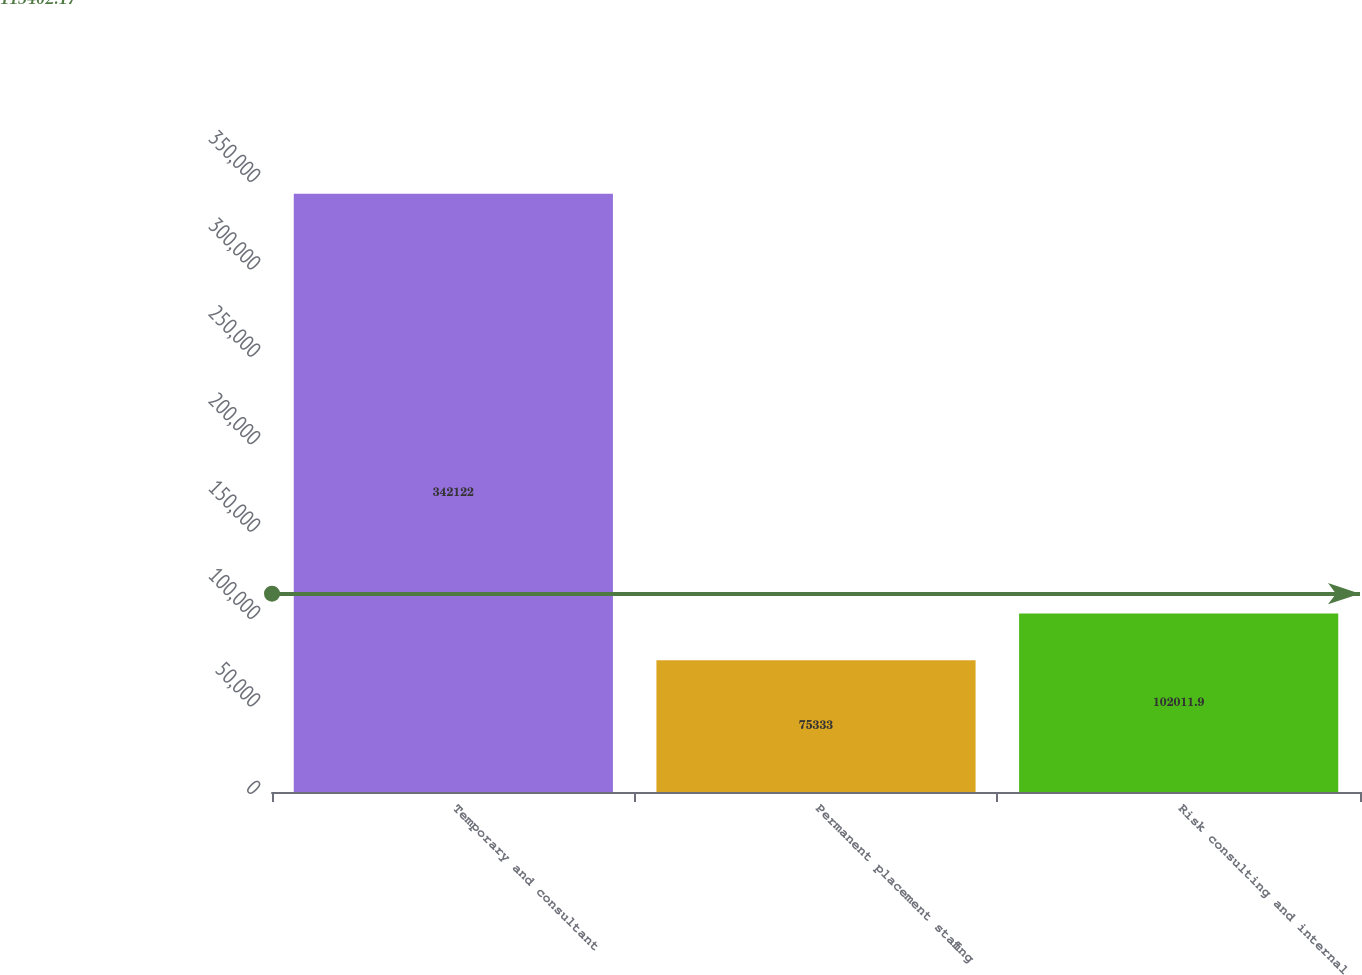Convert chart. <chart><loc_0><loc_0><loc_500><loc_500><bar_chart><fcel>Temporary and consultant<fcel>Permanent placement staffing<fcel>Risk consulting and internal<nl><fcel>342122<fcel>75333<fcel>102012<nl></chart> 